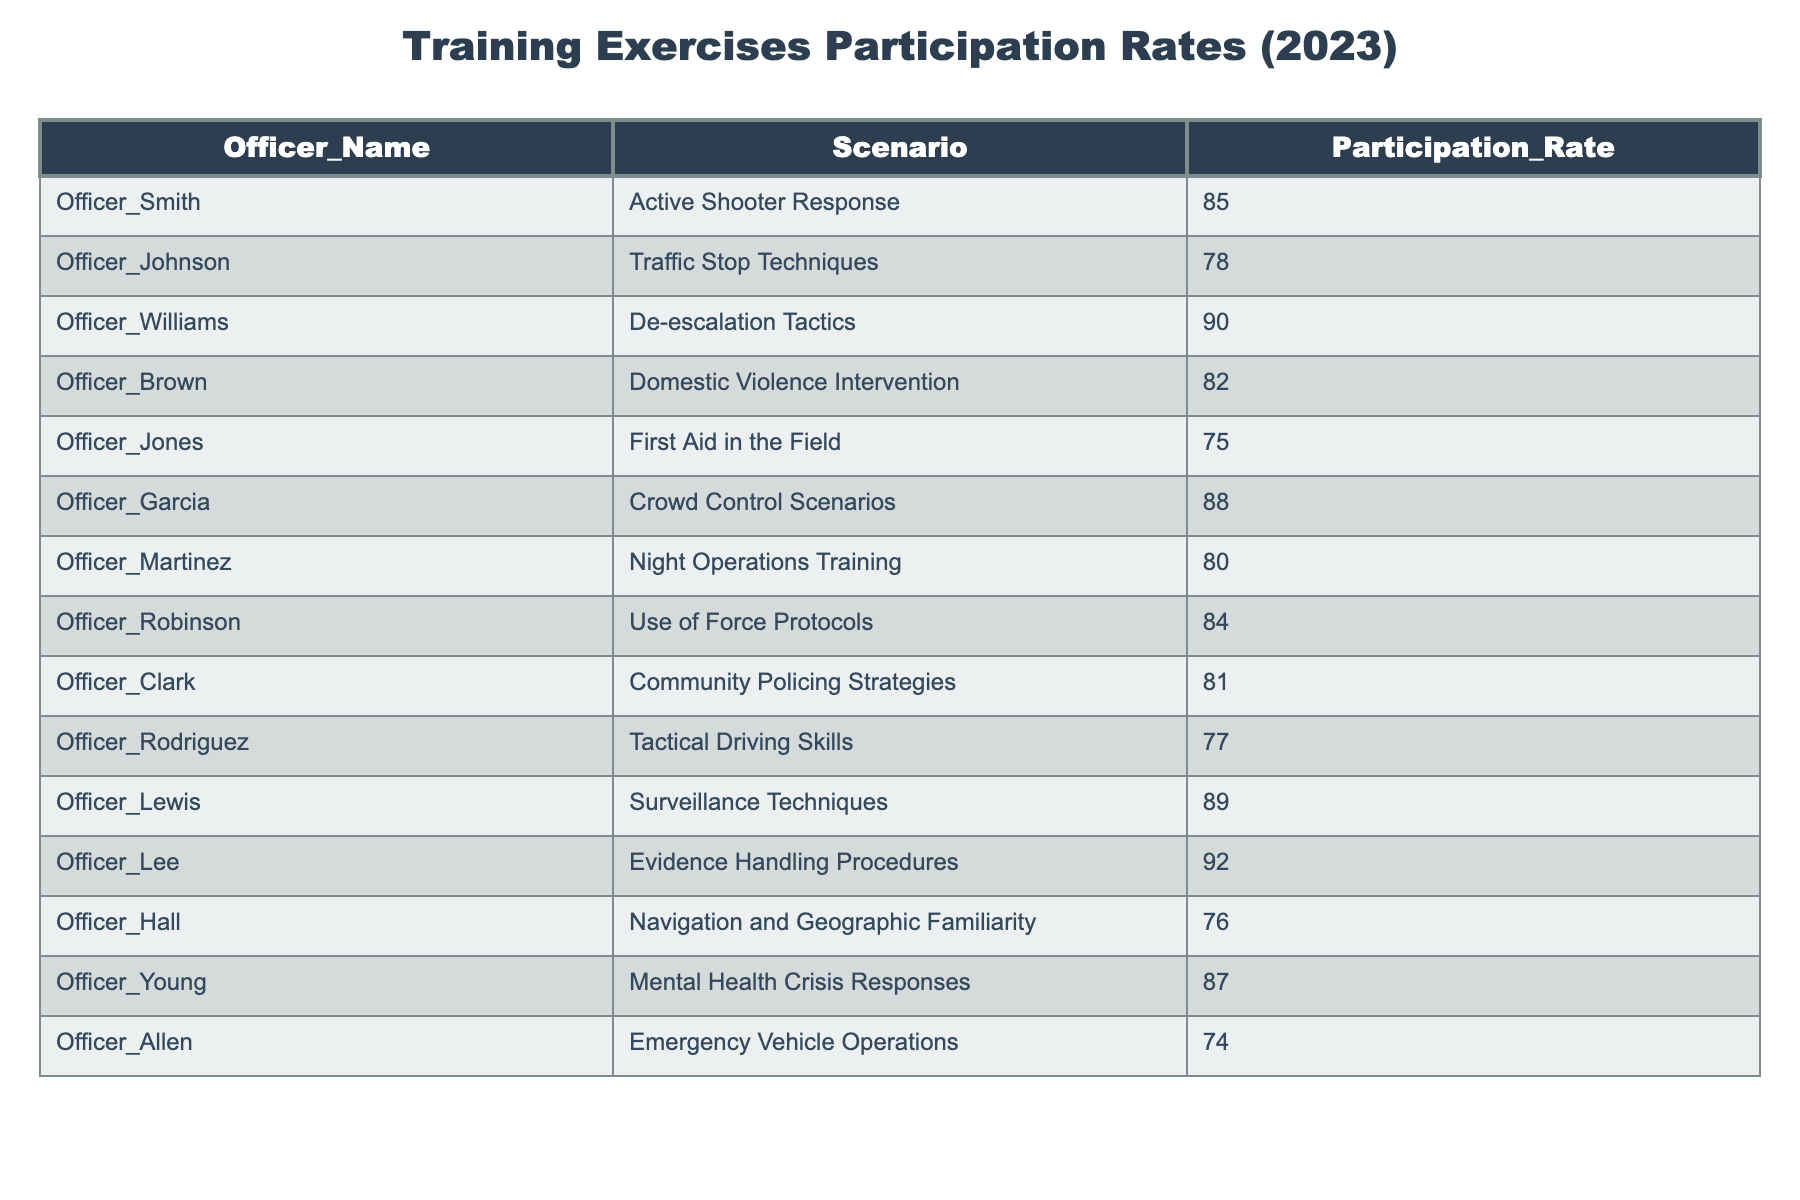What is the participation rate for Officer Williams in De-escalation Tactics? The table shows that Officer Williams has a participation rate of 90% in the De-escalation Tactics scenario.
Answer: 90 Which officer has the highest participation rate? By checking the participation rates listed in the table, Officer Lee has the highest at 92%.
Answer: Officer Lee Calculate the average participation rate of all officers. First, sum all the participation rates: 85 + 78 + 90 + 82 + 75 + 88 + 80 + 84 + 81 + 77 + 89 + 92 + 76 + 87 + 74 = 1282. There are 15 officers in total, so the average is 1282 / 15 = 85.47.
Answer: 85.47 Is Officer Allen's participation rate above or below the average participation rate? The average participation rate is 85.47. Officer Allen has a participation rate of 74, which is below the average.
Answer: Below How many officers have a participation rate of 80 or higher? Checking each officer's participation rate, the following officers meet the criteria: Officer Smith (85), Officer Williams (90), Officer Brown (82), Officer Garcia (88), Officer Lewis (89), Officer Lee (92), Officer Young (87) - a total of 7 officers.
Answer: 7 What is the difference in participation rates between Officer Lee and Officer Robinson? Officer Lee has a rate of 92%, while Officer Robinson has a rate of 84%. The difference is 92 - 84 = 8.
Answer: 8 Which scenarios have a participation rate lower than 80%, and how many are there? From the table, the following scenarios have rates below 80%: First Aid in the Field (75), Emergency Vehicle Operations (74), which totals 2 scenarios.
Answer: 2 Does any officer have a participation rate of exactly 75%? Yes, Officer Jones has a participation rate of 75%.
Answer: Yes Which officer improved their participation rate the most compared to the average? To determine this, we calculate the difference between the average (85.47) and each officer’s rate, focusing on those above average. Officer Lee (92) has the largest difference of 6.53, making the most significant improvement in comparison.
Answer: Officer Lee 